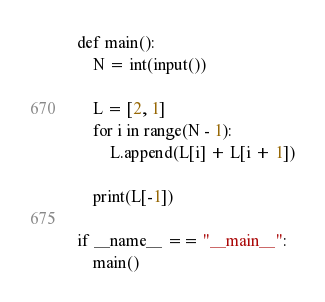Convert code to text. <code><loc_0><loc_0><loc_500><loc_500><_Python_>def main():
    N = int(input())

    L = [2, 1]
    for i in range(N - 1):
        L.append(L[i] + L[i + 1])

    print(L[-1])

if __name__ == "__main__":
    main()</code> 